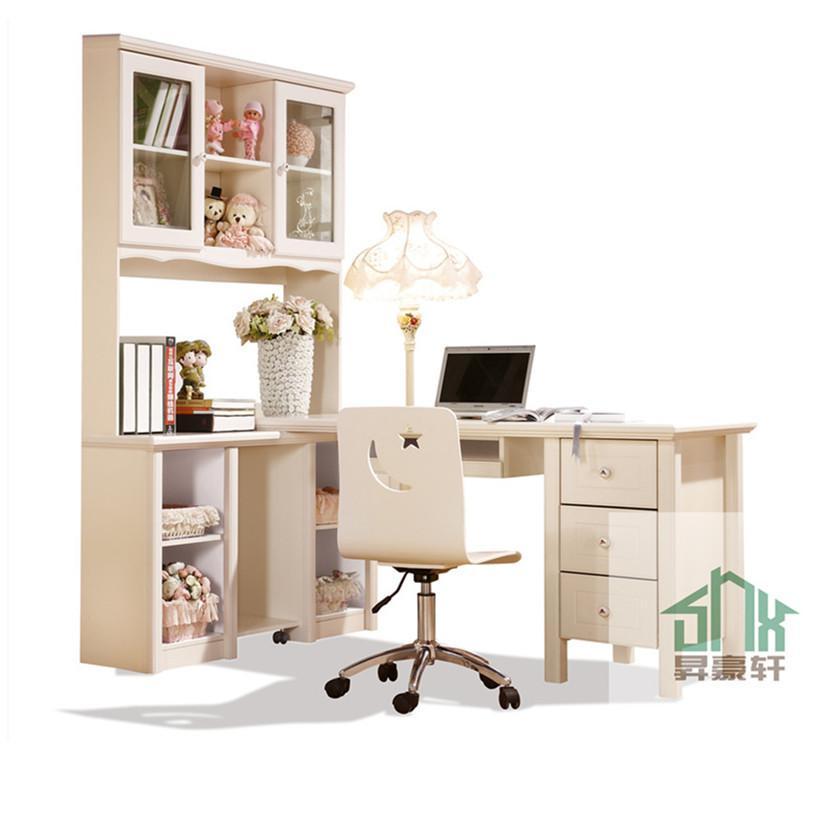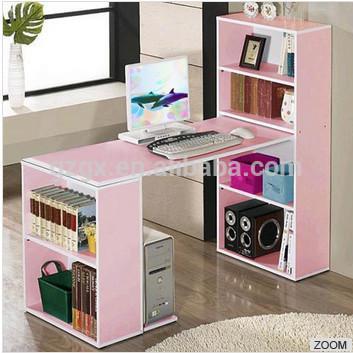The first image is the image on the left, the second image is the image on the right. Analyze the images presented: Is the assertion "There is a chair on wheels next to a desk." valid? Answer yes or no. Yes. The first image is the image on the left, the second image is the image on the right. Given the left and right images, does the statement "There is a chair pulled up to at least one of the desks." hold true? Answer yes or no. Yes. 